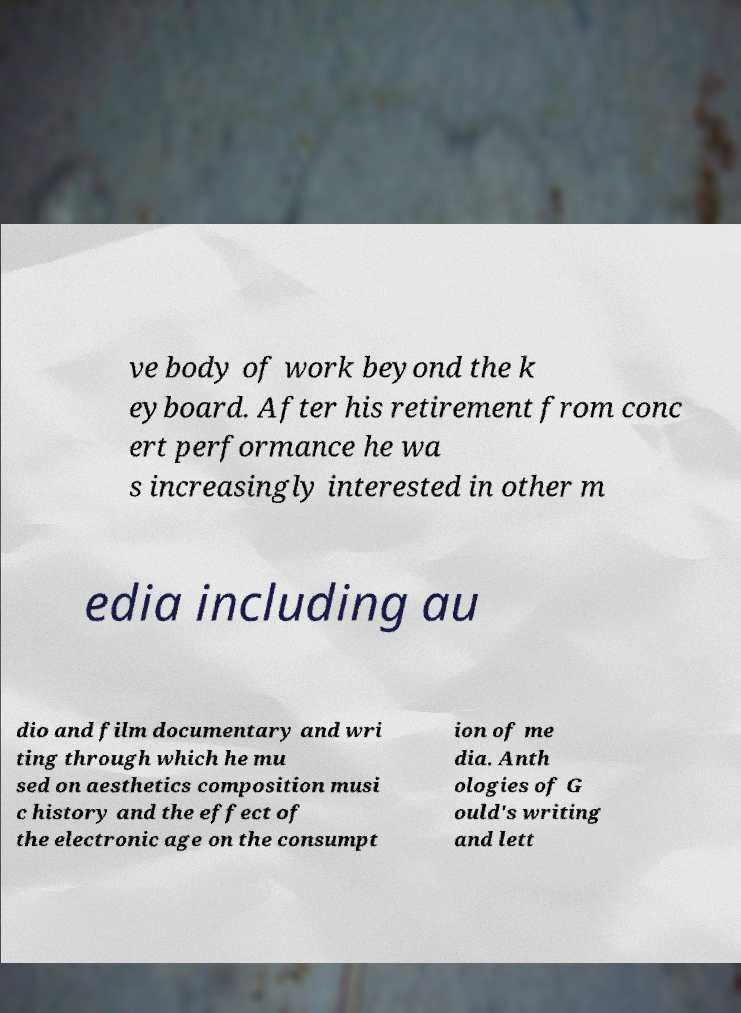Can you read and provide the text displayed in the image?This photo seems to have some interesting text. Can you extract and type it out for me? ve body of work beyond the k eyboard. After his retirement from conc ert performance he wa s increasingly interested in other m edia including au dio and film documentary and wri ting through which he mu sed on aesthetics composition musi c history and the effect of the electronic age on the consumpt ion of me dia. Anth ologies of G ould's writing and lett 